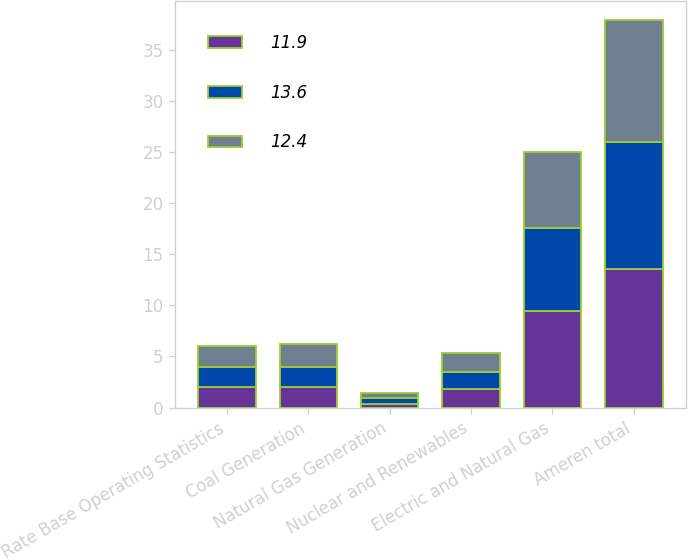Convert chart. <chart><loc_0><loc_0><loc_500><loc_500><stacked_bar_chart><ecel><fcel>Rate Base Operating Statistics<fcel>Coal Generation<fcel>Natural Gas Generation<fcel>Nuclear and Renewables<fcel>Electric and Natural Gas<fcel>Ameren total<nl><fcel>11.9<fcel>2<fcel>2<fcel>0.4<fcel>1.8<fcel>9.4<fcel>13.6<nl><fcel>13.6<fcel>2<fcel>2<fcel>0.5<fcel>1.7<fcel>8.2<fcel>12.4<nl><fcel>12.4<fcel>2<fcel>2.2<fcel>0.5<fcel>1.8<fcel>7.4<fcel>11.9<nl></chart> 